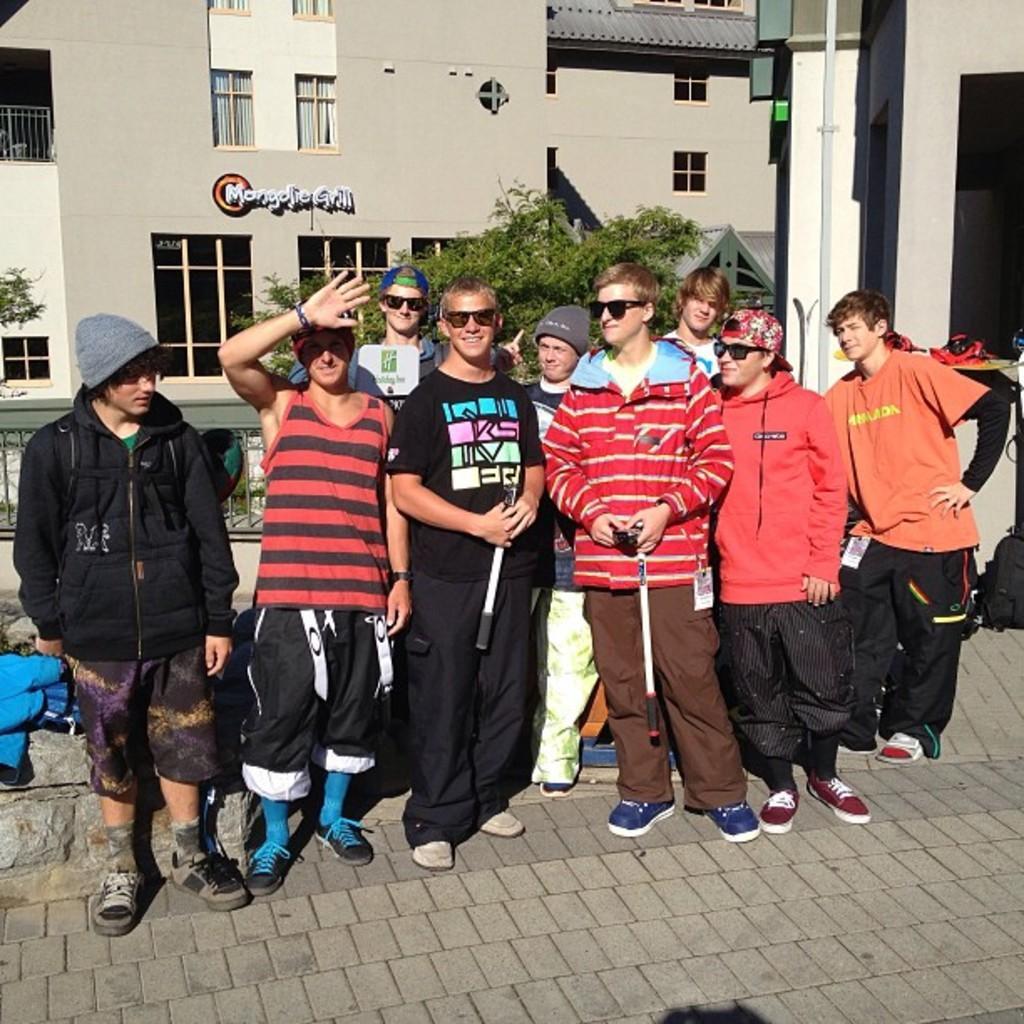Could you give a brief overview of what you see in this image? In the image there are group of men standing in a row and behind the men there is a tree and in the background there is a big house and there is a lot of sunlight falling on the surface. 